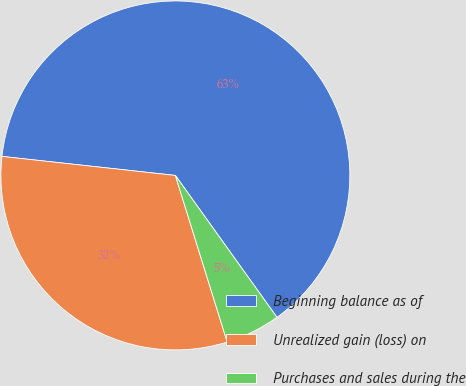<chart> <loc_0><loc_0><loc_500><loc_500><pie_chart><fcel>Beginning balance as of<fcel>Unrealized gain (loss) on<fcel>Purchases and sales during the<nl><fcel>63.37%<fcel>31.54%<fcel>5.09%<nl></chart> 